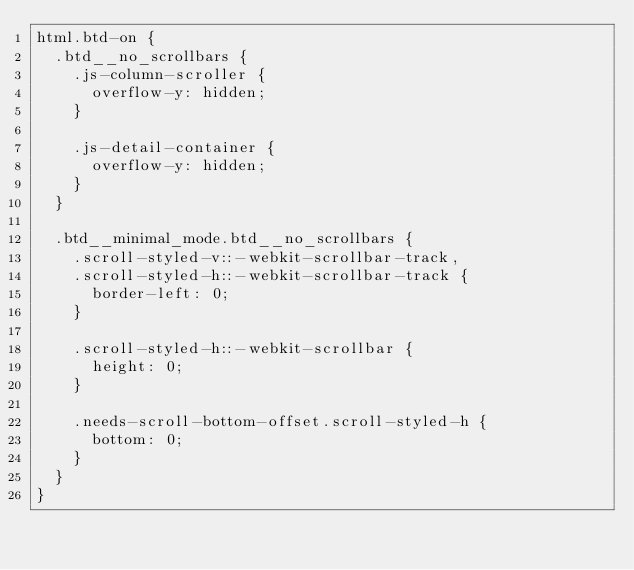Convert code to text. <code><loc_0><loc_0><loc_500><loc_500><_CSS_>html.btd-on {
  .btd__no_scrollbars {
    .js-column-scroller {
      overflow-y: hidden;
    }

    .js-detail-container {
      overflow-y: hidden;
    }
  }

  .btd__minimal_mode.btd__no_scrollbars {
    .scroll-styled-v::-webkit-scrollbar-track,
    .scroll-styled-h::-webkit-scrollbar-track {
      border-left: 0;
    }

    .scroll-styled-h::-webkit-scrollbar {
      height: 0;
    }

    .needs-scroll-bottom-offset.scroll-styled-h {
      bottom: 0;
    }
  }
}
</code> 